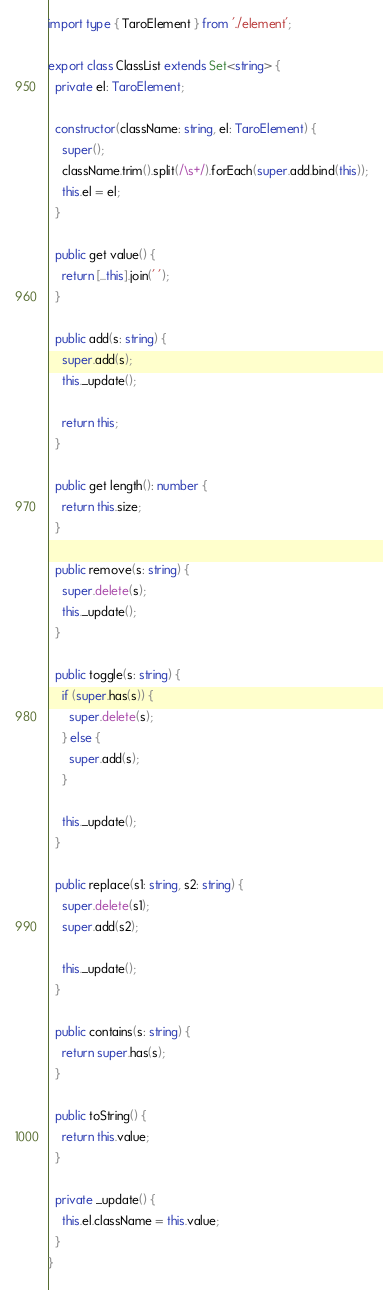<code> <loc_0><loc_0><loc_500><loc_500><_TypeScript_>import type { TaroElement } from './element';

export class ClassList extends Set<string> {
  private el: TaroElement;

  constructor(className: string, el: TaroElement) {
    super();
    className.trim().split(/\s+/).forEach(super.add.bind(this));
    this.el = el;
  }

  public get value() {
    return [...this].join(' ');
  }

  public add(s: string) {
    super.add(s);
    this._update();

    return this;
  }

  public get length(): number {
    return this.size;
  }

  public remove(s: string) {
    super.delete(s);
    this._update();
  }

  public toggle(s: string) {
    if (super.has(s)) {
      super.delete(s);
    } else {
      super.add(s);
    }

    this._update();
  }

  public replace(s1: string, s2: string) {
    super.delete(s1);
    super.add(s2);

    this._update();
  }

  public contains(s: string) {
    return super.has(s);
  }

  public toString() {
    return this.value;
  }

  private _update() {
    this.el.className = this.value;
  }
}
</code> 